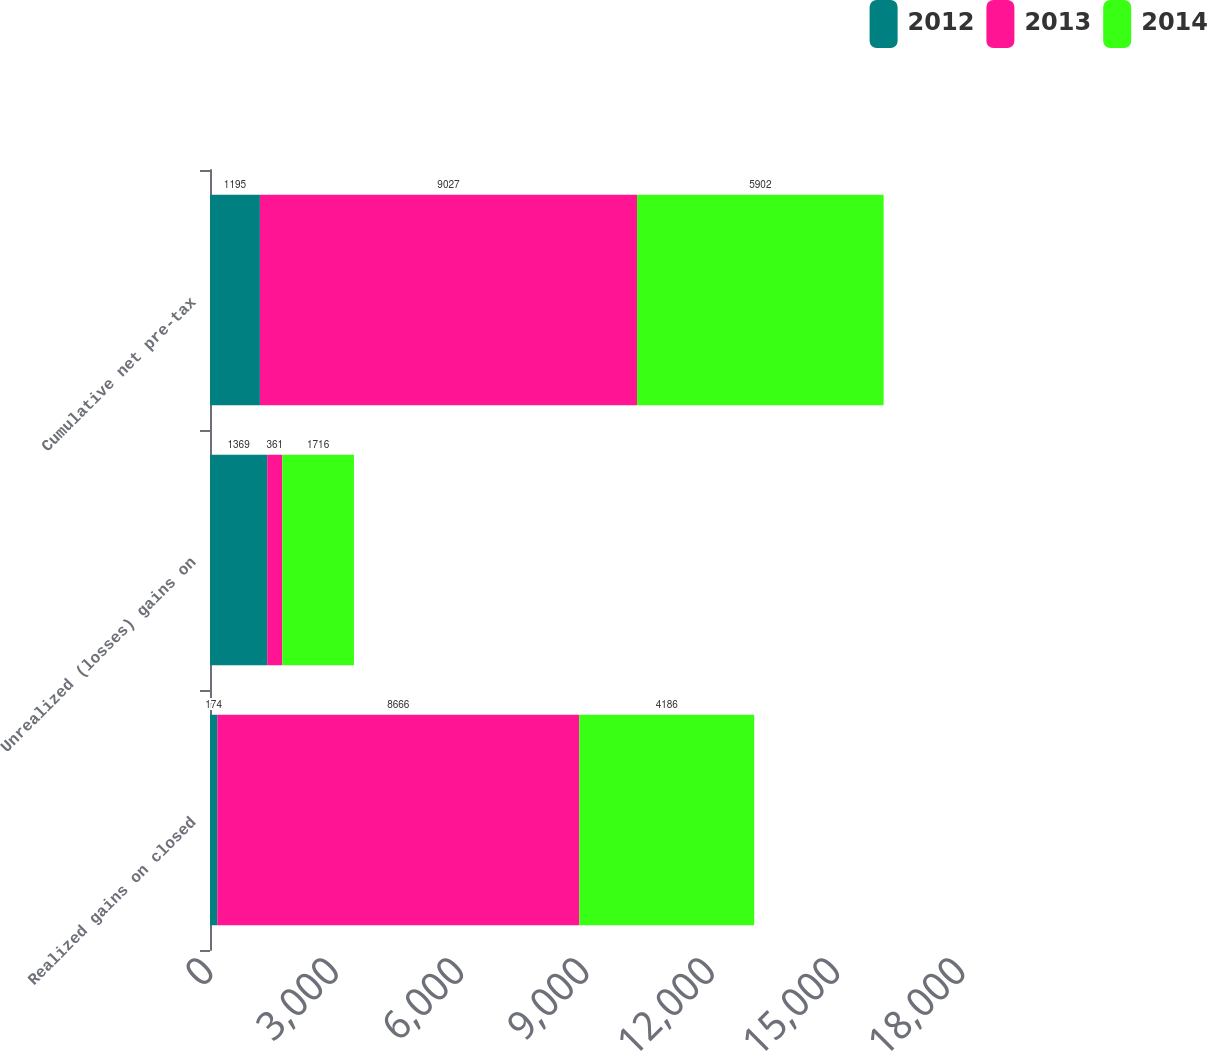Convert chart to OTSL. <chart><loc_0><loc_0><loc_500><loc_500><stacked_bar_chart><ecel><fcel>Realized gains on closed<fcel>Unrealized (losses) gains on<fcel>Cumulative net pre-tax<nl><fcel>2012<fcel>174<fcel>1369<fcel>1195<nl><fcel>2013<fcel>8666<fcel>361<fcel>9027<nl><fcel>2014<fcel>4186<fcel>1716<fcel>5902<nl></chart> 